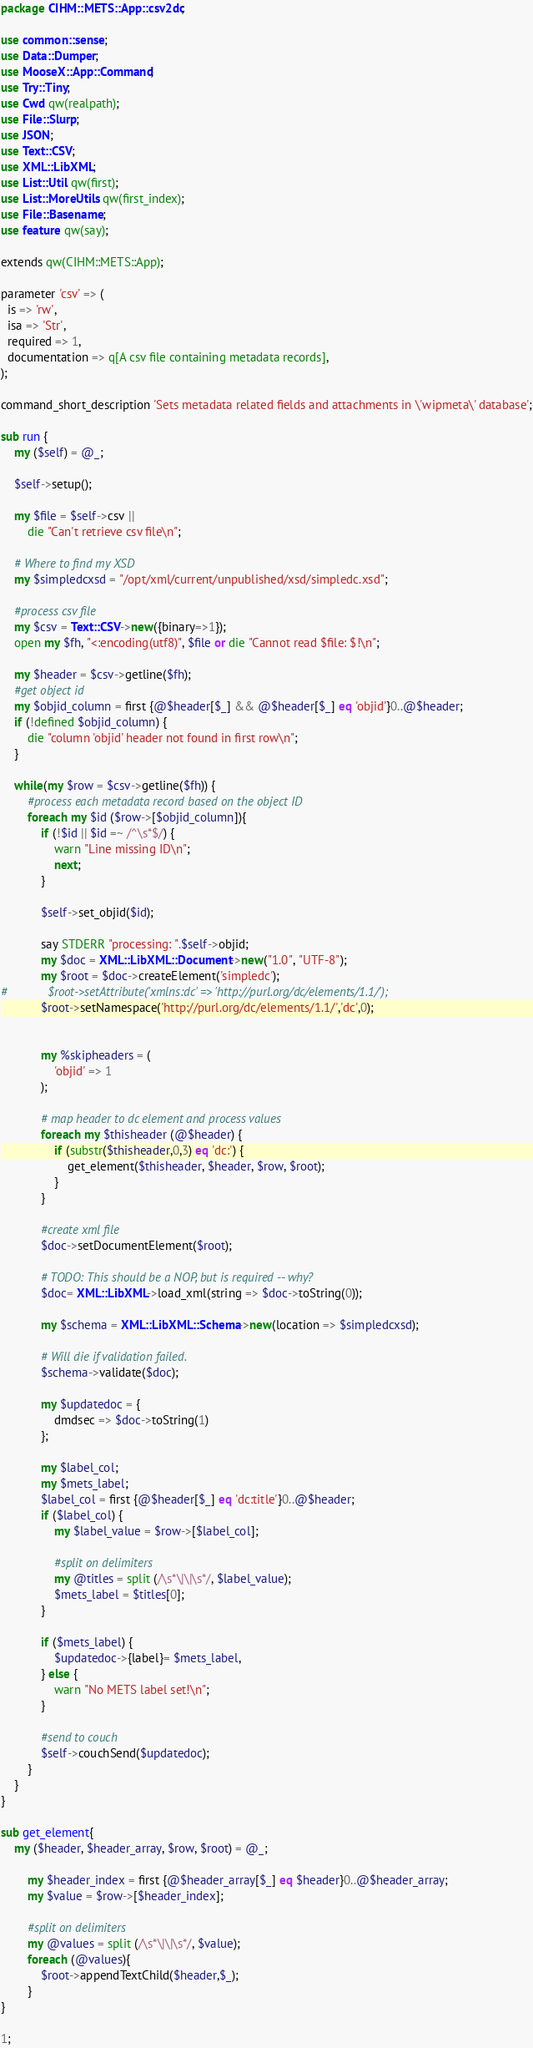Convert code to text. <code><loc_0><loc_0><loc_500><loc_500><_Perl_>package CIHM::METS::App::csv2dc;

use common::sense;
use Data::Dumper;
use MooseX::App::Command;
use Try::Tiny;
use Cwd qw(realpath);
use File::Slurp;
use JSON;
use Text::CSV;
use XML::LibXML;
use List::Util qw(first);
use List::MoreUtils qw(first_index);
use File::Basename;
use feature qw(say);

extends qw(CIHM::METS::App);

parameter 'csv' => (
  is => 'rw',
  isa => 'Str',
  required => 1,
  documentation => q[A csv file containing metadata records],
);

command_short_description 'Sets metadata related fields and attachments in \'wipmeta\' database';

sub run {
    my ($self) = @_;

    $self->setup();

    my $file = $self->csv ||
        die "Can't retrieve csv file\n";

    # Where to find my XSD
    my $simpledcxsd = "/opt/xml/current/unpublished/xsd/simpledc.xsd";

    #process csv file
    my $csv = Text::CSV->new({binary=>1});
    open my $fh, "<:encoding(utf8)", $file or die "Cannot read $file: $!\n";

    my $header = $csv->getline($fh);
    #get object id
    my $objid_column = first {@$header[$_] && @$header[$_] eq 'objid'}0..@$header;
    if (!defined $objid_column) {
        die "column 'objid' header not found in first row\n"; 
    }

    while(my $row = $csv->getline($fh)) {
        #process each metadata record based on the object ID	
        foreach my $id ($row->[$objid_column]){
            if (!$id || $id =~ /^\s*$/) {
                warn "Line missing ID\n";
                next;
            }
		
            $self->set_objid($id);

            say STDERR "processing: ".$self->objid;
            my $doc = XML::LibXML::Document->new("1.0", "UTF-8");
            my $root = $doc->createElement('simpledc');
#            $root->setAttribute('xmlns:dc' => 'http://purl.org/dc/elements/1.1/');
            $root->setNamespace('http://purl.org/dc/elements/1.1/','dc',0);
            

            my %skipheaders = (
                'objid' => 1
            );

            # map header to dc element and process values	
            foreach my $thisheader (@$header) {
                if (substr($thisheader,0,3) eq 'dc:') {
                    get_element($thisheader, $header, $row, $root);
                }
            }
	  	
            #create xml file
            $doc->setDocumentElement($root);

            # TODO: This should be a NOP, but is required -- why?
            $doc= XML::LibXML->load_xml(string => $doc->toString(0));

            my $schema = XML::LibXML::Schema->new(location => $simpledcxsd);

            # Will die if validation failed.
            $schema->validate($doc);
            
            my $updatedoc = {
                dmdsec => $doc->toString(1)
            };

            my $label_col;
            my $mets_label;
            $label_col = first {@$header[$_] eq 'dc:title'}0..@$header;
            if ($label_col) {
                my $label_value = $row->[$label_col];

                #split on delimiters
                my @titles = split (/\s*\|\|\s*/, $label_value);
                $mets_label = $titles[0];
            }

            if ($mets_label) {
                $updatedoc->{label}= $mets_label,
            } else {
                warn "No METS label set!\n";
            }
            
            #send to couch
            $self->couchSend($updatedoc);
        }
    }
}

sub get_element{
	my ($header, $header_array, $row, $root) = @_;

        my $header_index = first {@$header_array[$_] eq $header}0..@$header_array;
        my $value = $row->[$header_index];
		
        #split on delimiters
        my @values = split (/\s*\|\|\s*/, $value);
        foreach (@values){
            $root->appendTextChild($header,$_);
        }	
}

1;
</code> 